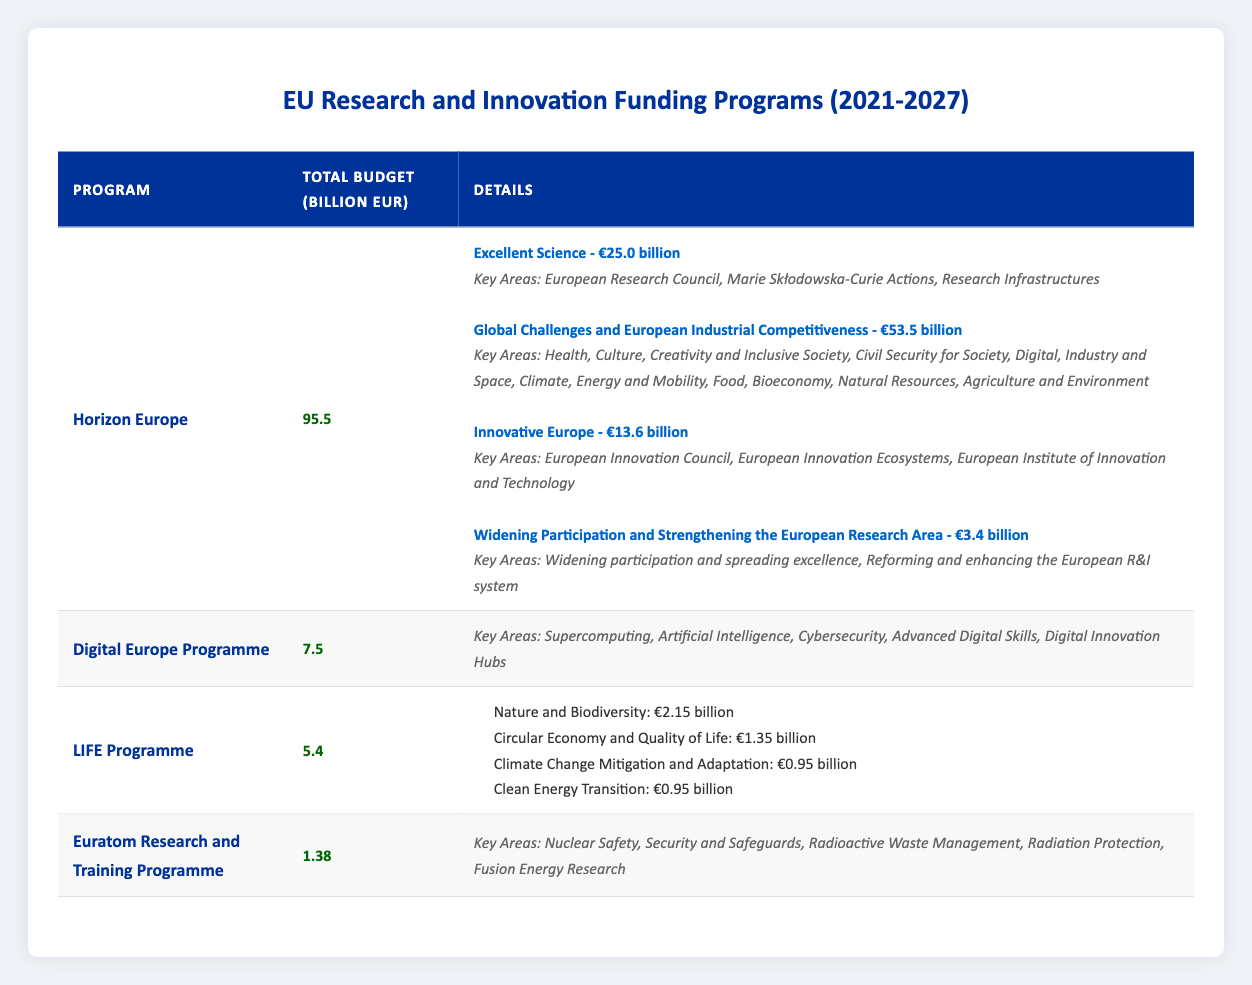What is the total budget of Horizon Europe? The table clearly states that the total budget for Horizon Europe is listed under the "Total Budget (billion EUR)" column, which shows a value of 95.5 billion EUR.
Answer: 95.5 billion EUR Which pillar of Horizon Europe has the highest budget? In the breakdown of Horizon Europe's budget, the pillar "Global Challenges and European Industrial Competitiveness" has a budget of 53.5 billion EUR, which is higher than the budgets of the other pillars.
Answer: Global Challenges and European Industrial Competitiveness What is the total budget for the LIFE Programme? The total budget for the LIFE Programme is provided directly in the table under the "Total Budget (billion EUR)" column, which states 5.4 billion EUR.
Answer: 5.4 billion EUR Is there a program with a total budget under 2 billion EUR? By scanning through the "Total Budget (billion EUR)" column, it can be noted that Euratom Research and Training Programme has a total budget of 1.38 billion EUR, which is under 2 billion EUR.
Answer: Yes What is the total budget allocated to the "Excellent Science" pillar in Horizon Europe? The table shows that the budget for the "Excellent Science" pillar in Horizon Europe is 25.0 billion EUR, as listed under the "Budget (billion EUR)" for that pillar in the breakdown.
Answer: 25.0 billion EUR What proportion of the total budget does the "Innovative Europe" pillar represent in Horizon Europe? The budget for "Innovative Europe" is 13.6 billion EUR. To find the proportion, divide it by the total budget of Horizon Europe (95.5 billion EUR). The calculation is 13.6/95.5 = 0.142 or approximately 14.2%.
Answer: Approximately 14.2% How much more funding is allocated to "Global Challenges and European Industrial Competitiveness" than "Widening Participation and Strengthening the European Research Area"? The budget for "Global Challenges and European Industrial Competitiveness" is 53.5 billion EUR, and for "Widening Participation and Strengthening the European Research Area," it is 3.4 billion EUR. The difference is 53.5 - 3.4 = 50.1 billion EUR.
Answer: 50.1 billion EUR Which program has the largest number of key areas mentioned? The Horizon Europe program has 6 key areas listed under the pillar "Global Challenges and European Industrial Competitiveness," which is more than any other program's key areas.
Answer: Horizon Europe What is the combined budget of all the sub-programs in the LIFE Programme? The combined budgets of the sub-programs can be calculated by adding the individual budgets: 2.15 + 1.35 + 0.95 + 0.95 = 5.4 billion EUR, which is the total budget for the LIFE Programme.
Answer: 5.4 billion EUR 